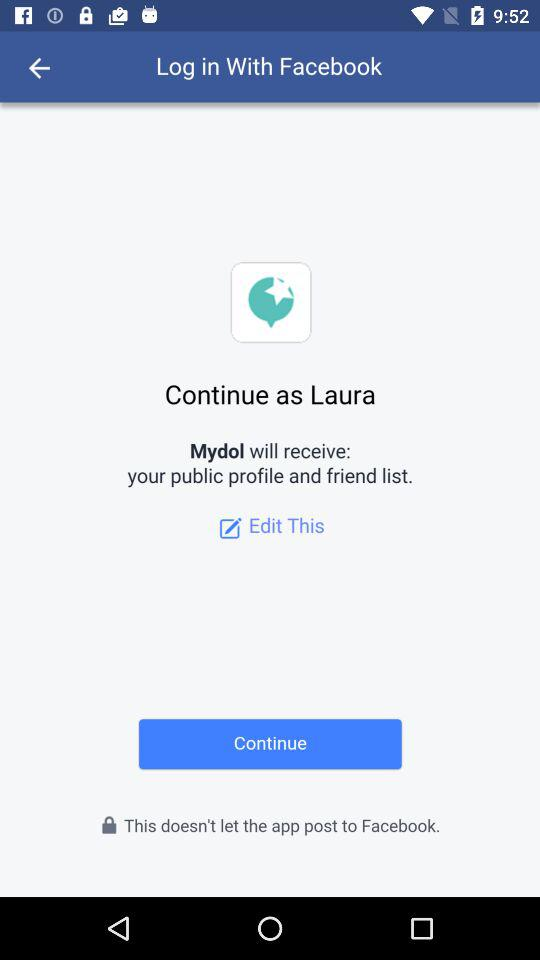Who will receive the public profile and friend list? The public profile and friend list will be received by "Mydol". 